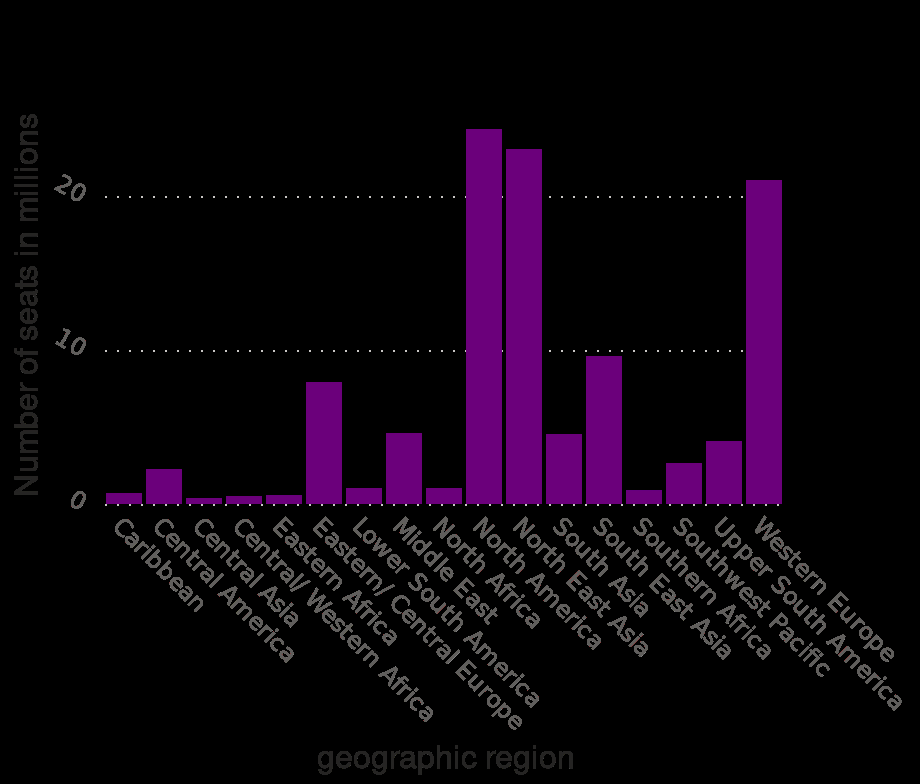<image>
please enumerates aspects of the construction of the chart Seat capacity in the airline industry in the week of May 06 , 2019 , by region (in millions) is a bar graph. The y-axis measures Number of seats in millions with linear scale from 0 to 20 while the x-axis shows geographic region with categorical scale starting with Caribbean and ending with . What does the x-axis represent in the graph? The x-axis represents the geographic regions. 